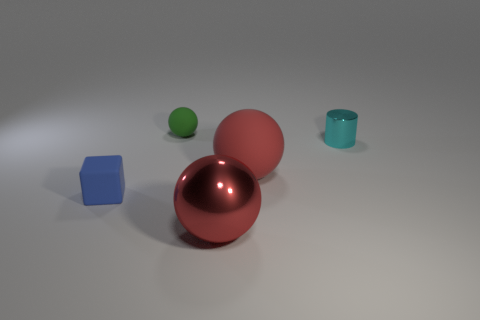There is a big thing that is the same color as the big matte sphere; what is it made of?
Ensure brevity in your answer.  Metal. Is there any other thing that has the same shape as the cyan shiny thing?
Give a very brief answer. No. Are there an equal number of small blue cubes right of the green object and tiny gray cylinders?
Offer a very short reply. Yes. Are there any small metallic cylinders in front of the green matte sphere?
Give a very brief answer. Yes. How many rubber things are blocks or large green cubes?
Provide a short and direct response. 1. There is a small cyan metal thing; what number of small matte things are behind it?
Make the answer very short. 1. Is there a green thing of the same size as the blue block?
Your answer should be very brief. Yes. Is there a matte ball that has the same color as the large metal ball?
Ensure brevity in your answer.  Yes. What number of other large balls are the same color as the big matte ball?
Keep it short and to the point. 1. Do the big metal thing and the rubber object that is on the right side of the small green matte thing have the same color?
Your answer should be very brief. Yes. 